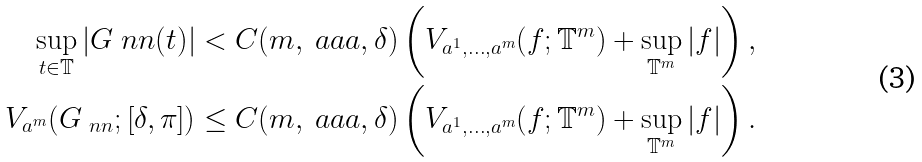<formula> <loc_0><loc_0><loc_500><loc_500>\sup _ { t \in \mathbb { T } } | G _ { \ } n n ( t ) | < C ( m , \ a a a , \delta ) \left ( V _ { \L a ^ { 1 } , \dots , \L a ^ { m } } ( f ; \mathbb { T } ^ { m } ) + \sup _ { \mathbb { T } ^ { m } } | f | \right ) , \\ V _ { \L a ^ { m } } ( G _ { \ n n } ; [ \delta , \pi ] ) \leq C ( m , \ a a a , \delta ) \left ( V _ { \L a ^ { 1 } , \dots , \L a ^ { m } } ( f ; \mathbb { T } ^ { m } ) + \sup _ { \mathbb { T } ^ { m } } | f | \right ) .</formula> 